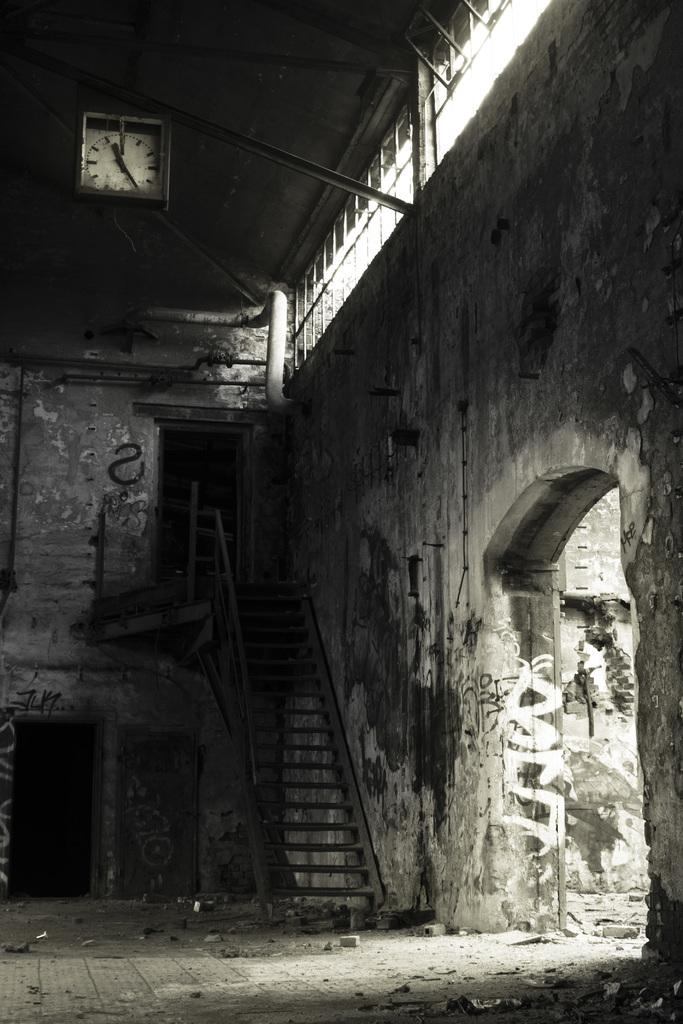What type of architectural feature is present in the image? There are stairs in the image. What can be seen attached to the wall in the image? There is a clock attached to the wall in the image. What allows natural light to enter the space in the image? There are windows in the image. What part of a building can be seen in the image? The inner part of a building is visible in the image. What type of straw is being used to play basketball in the image? There is no straw or basketball present in the image. 